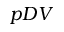Convert formula to latex. <formula><loc_0><loc_0><loc_500><loc_500>p D V</formula> 